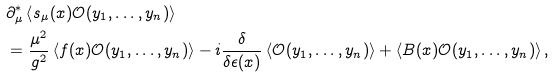Convert formula to latex. <formula><loc_0><loc_0><loc_500><loc_500>& \partial _ { \mu } ^ { * } \left \langle s _ { \mu } ( x ) \mathcal { O } ( y _ { 1 } , \dots , y _ { n } ) \right \rangle \\ & = \frac { \mu ^ { 2 } } { g ^ { 2 } } \left \langle f ( x ) \mathcal { O } ( y _ { 1 } , \dots , y _ { n } ) \right \rangle - i \frac { \delta } { \delta \epsilon ( x ) } \left \langle \mathcal { O } ( y _ { 1 } , \dots , y _ { n } ) \right \rangle + \left \langle B ( x ) \mathcal { O } ( y _ { 1 } , \dots , y _ { n } ) \right \rangle ,</formula> 